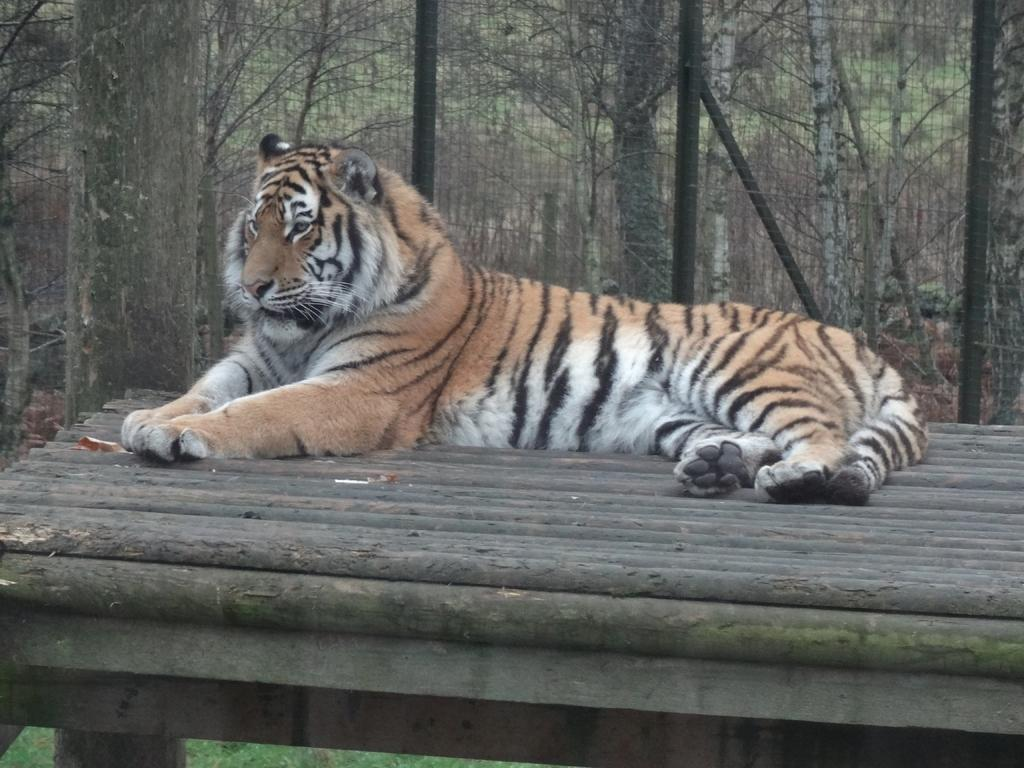What is the main subject in the center of the image? There is a tiger in the center of the image. Where is the tiger located? The tiger is on a table. What can be seen in the background of the image? There are trees and a mesh visible in the background of the image. How many frogs are sitting on the tiger's back in the image? There are no frogs present in the image, so it is not possible to determine how many might be sitting on the tiger's back. 